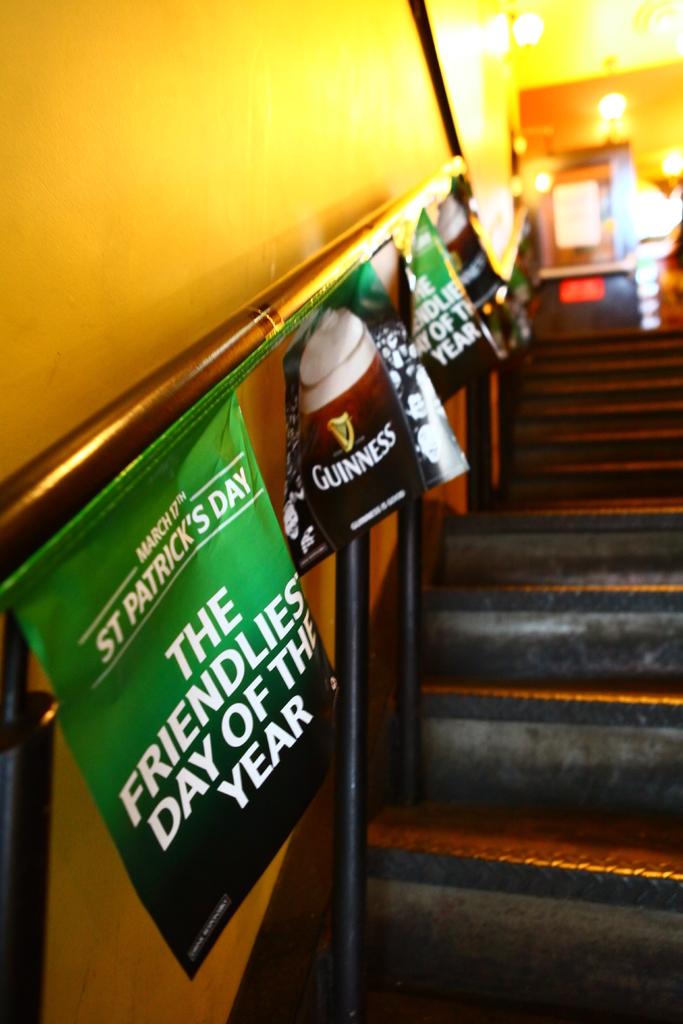What is the friendliest day of the year?
Keep it short and to the point. St. patrick's day. What brand beer is this?
Keep it short and to the point. Guinness. 